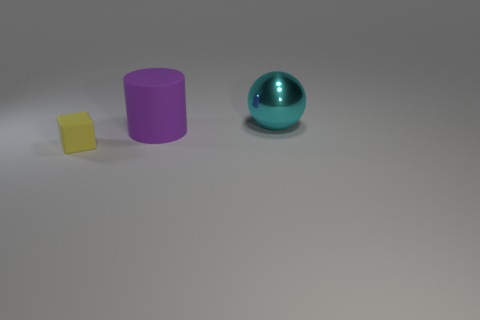Are there any shadows visible in the image, and what do they tell us about the lighting? Yes, each object casts a shadow which indicates a light source above and slightly to the front of the objects. The shadows are soft-edged, suggesting the light source is not extremely close, and diffused, possibly to avoid harshness and provide more uniform illumination. 